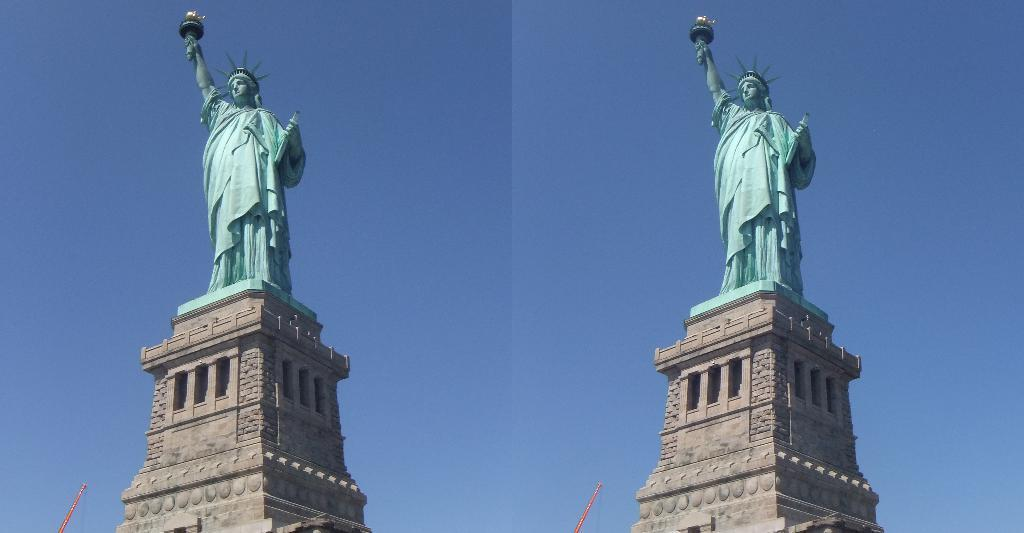What type of artwork is featured in the image? The image contains a collage. What famous landmark can be seen in the collage? The Statue of Liberty is present in the collage. What object is located at the bottom of the image? There is a stick at the bottom of the image. What is visible in the background of the image? The sky is visible in the image. How would you describe the weather based on the sky in the image? The sky appears to be cloudy in the image. Can you see the thumb of approval in the image? There is no thumb or approval symbol present in the image. What type of boot is featured in the image? There is no boot present in the image. 